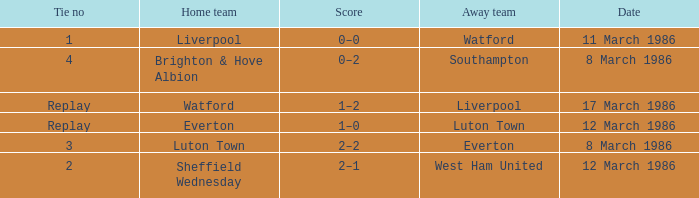What was the tie resulting from Sheffield Wednesday's game? 2.0. 